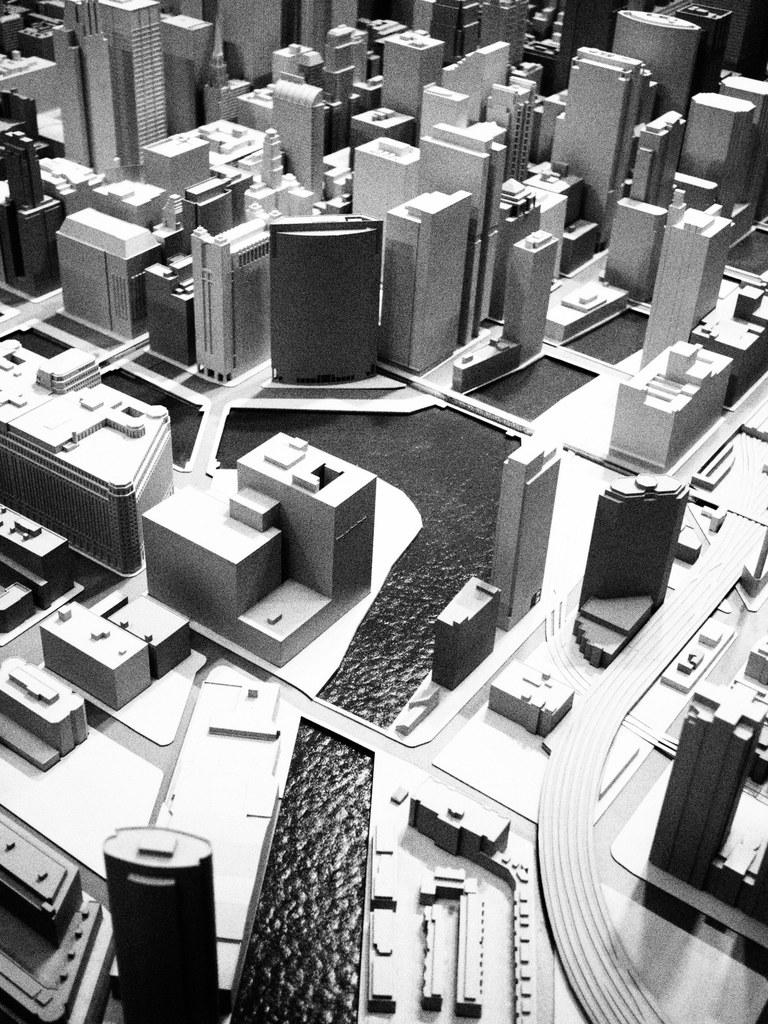What type of structures can be seen in the image? There are buildings in the image. What natural element is visible in the image? There is water visible in the image. Where is the doll located in the image? There is no doll present in the image. What type of industry can be seen in the image? The image does not depict any specific industry; it only shows buildings and water. 